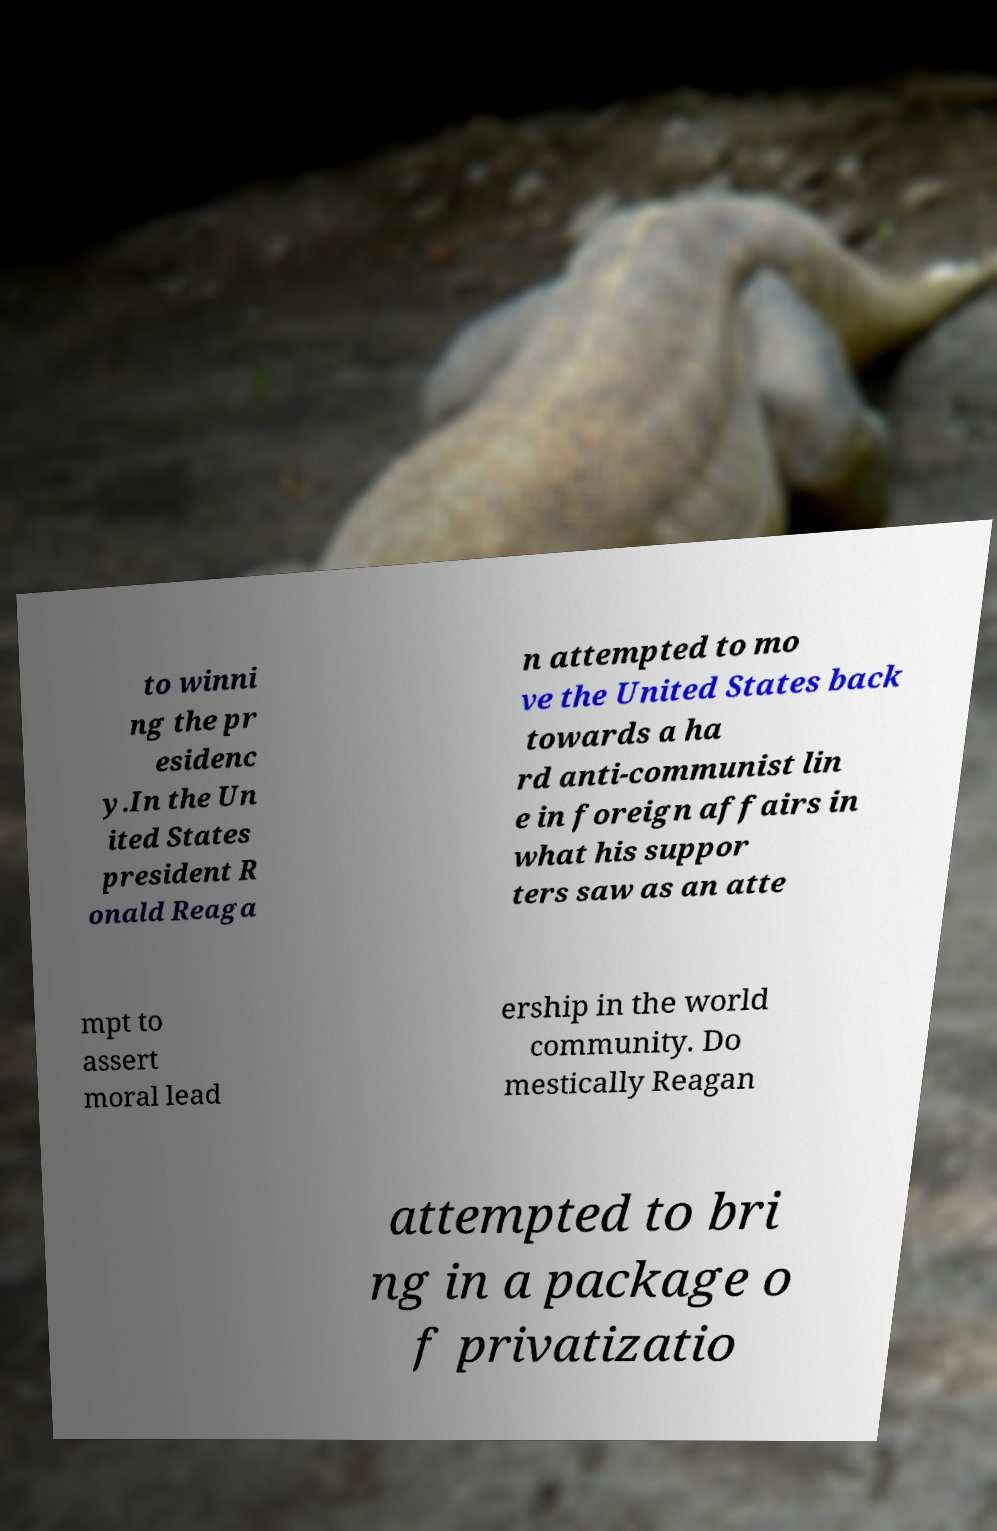I need the written content from this picture converted into text. Can you do that? to winni ng the pr esidenc y.In the Un ited States president R onald Reaga n attempted to mo ve the United States back towards a ha rd anti-communist lin e in foreign affairs in what his suppor ters saw as an atte mpt to assert moral lead ership in the world community. Do mestically Reagan attempted to bri ng in a package o f privatizatio 